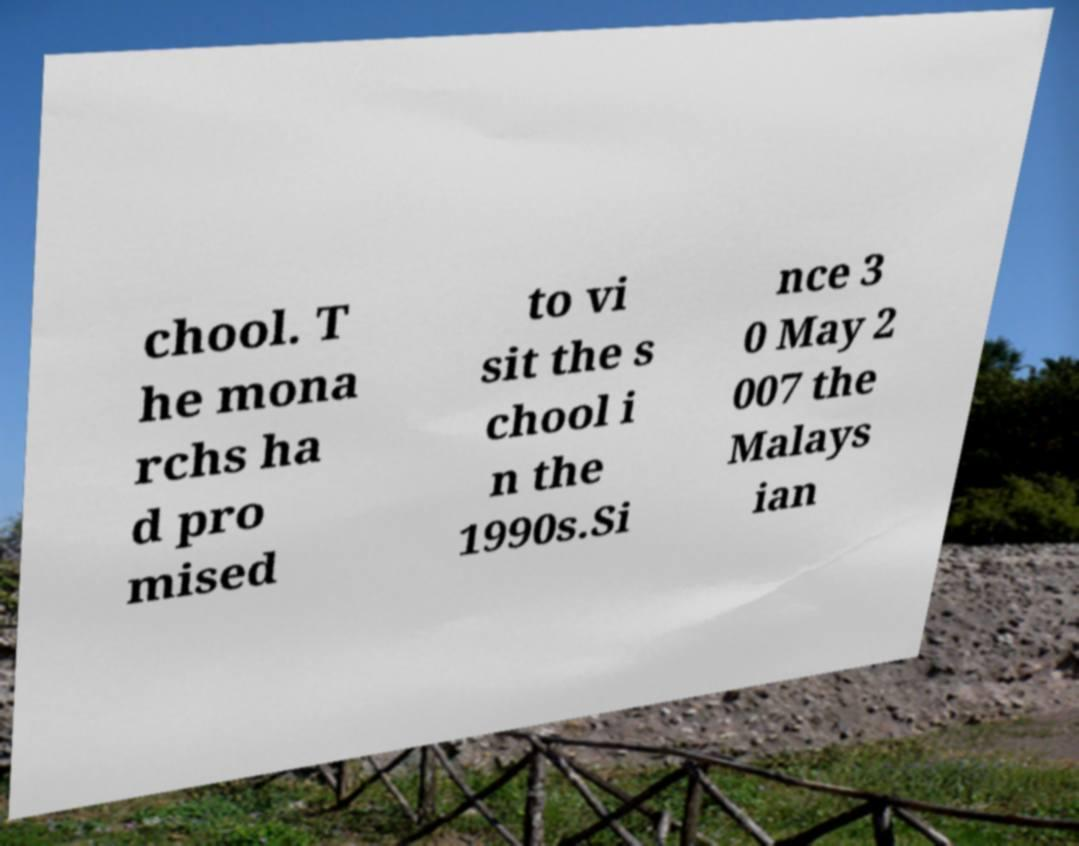Please read and relay the text visible in this image. What does it say? chool. T he mona rchs ha d pro mised to vi sit the s chool i n the 1990s.Si nce 3 0 May 2 007 the Malays ian 